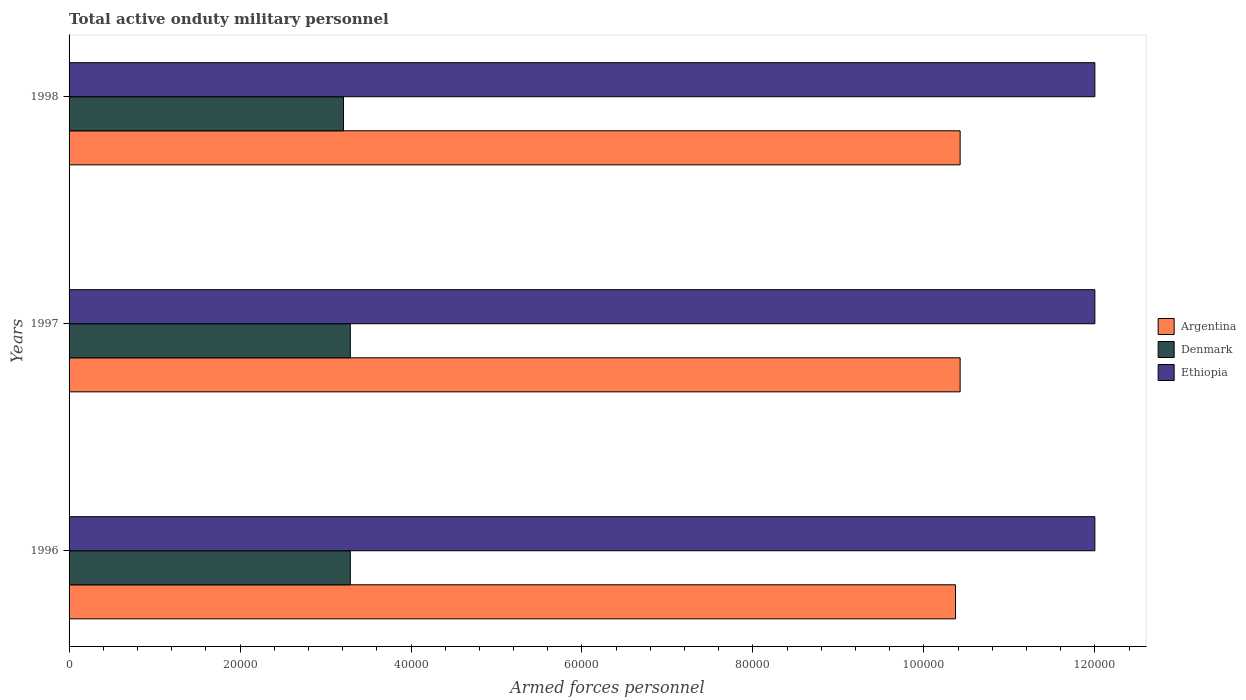How many different coloured bars are there?
Keep it short and to the point. 3. How many groups of bars are there?
Make the answer very short. 3. How many bars are there on the 1st tick from the bottom?
Offer a very short reply. 3. What is the number of armed forces personnel in Ethiopia in 1997?
Give a very brief answer. 1.20e+05. Across all years, what is the maximum number of armed forces personnel in Denmark?
Your answer should be compact. 3.29e+04. Across all years, what is the minimum number of armed forces personnel in Argentina?
Give a very brief answer. 1.04e+05. What is the total number of armed forces personnel in Argentina in the graph?
Offer a terse response. 3.12e+05. What is the difference between the number of armed forces personnel in Denmark in 1997 and that in 1998?
Make the answer very short. 800. What is the difference between the number of armed forces personnel in Ethiopia in 1997 and the number of armed forces personnel in Denmark in 1998?
Your answer should be very brief. 8.79e+04. What is the average number of armed forces personnel in Argentina per year?
Provide a short and direct response. 1.04e+05. In the year 1997, what is the difference between the number of armed forces personnel in Argentina and number of armed forces personnel in Ethiopia?
Keep it short and to the point. -1.58e+04. What is the ratio of the number of armed forces personnel in Argentina in 1996 to that in 1997?
Make the answer very short. 0.99. Is the number of armed forces personnel in Denmark in 1996 less than that in 1997?
Offer a terse response. No. Is the difference between the number of armed forces personnel in Argentina in 1997 and 1998 greater than the difference between the number of armed forces personnel in Ethiopia in 1997 and 1998?
Offer a terse response. No. What is the difference between the highest and the lowest number of armed forces personnel in Argentina?
Keep it short and to the point. 540. What does the 3rd bar from the bottom in 1997 represents?
Keep it short and to the point. Ethiopia. Is it the case that in every year, the sum of the number of armed forces personnel in Argentina and number of armed forces personnel in Denmark is greater than the number of armed forces personnel in Ethiopia?
Offer a terse response. Yes. How many bars are there?
Your answer should be very brief. 9. Are all the bars in the graph horizontal?
Give a very brief answer. Yes. How many years are there in the graph?
Offer a terse response. 3. Are the values on the major ticks of X-axis written in scientific E-notation?
Give a very brief answer. No. Does the graph contain any zero values?
Offer a terse response. No. Does the graph contain grids?
Make the answer very short. No. What is the title of the graph?
Give a very brief answer. Total active onduty military personnel. Does "Zimbabwe" appear as one of the legend labels in the graph?
Your response must be concise. No. What is the label or title of the X-axis?
Offer a very short reply. Armed forces personnel. What is the label or title of the Y-axis?
Give a very brief answer. Years. What is the Armed forces personnel in Argentina in 1996?
Provide a short and direct response. 1.04e+05. What is the Armed forces personnel in Denmark in 1996?
Make the answer very short. 3.29e+04. What is the Armed forces personnel in Ethiopia in 1996?
Keep it short and to the point. 1.20e+05. What is the Armed forces personnel in Argentina in 1997?
Provide a short and direct response. 1.04e+05. What is the Armed forces personnel in Denmark in 1997?
Provide a short and direct response. 3.29e+04. What is the Armed forces personnel of Argentina in 1998?
Your answer should be very brief. 1.04e+05. What is the Armed forces personnel in Denmark in 1998?
Provide a short and direct response. 3.21e+04. Across all years, what is the maximum Armed forces personnel in Argentina?
Provide a short and direct response. 1.04e+05. Across all years, what is the maximum Armed forces personnel of Denmark?
Offer a terse response. 3.29e+04. Across all years, what is the maximum Armed forces personnel in Ethiopia?
Your answer should be compact. 1.20e+05. Across all years, what is the minimum Armed forces personnel in Argentina?
Offer a very short reply. 1.04e+05. Across all years, what is the minimum Armed forces personnel of Denmark?
Offer a terse response. 3.21e+04. Across all years, what is the minimum Armed forces personnel of Ethiopia?
Keep it short and to the point. 1.20e+05. What is the total Armed forces personnel of Argentina in the graph?
Your answer should be compact. 3.12e+05. What is the total Armed forces personnel in Denmark in the graph?
Keep it short and to the point. 9.79e+04. What is the total Armed forces personnel of Ethiopia in the graph?
Provide a succinct answer. 3.60e+05. What is the difference between the Armed forces personnel of Argentina in 1996 and that in 1997?
Give a very brief answer. -540. What is the difference between the Armed forces personnel in Denmark in 1996 and that in 1997?
Provide a succinct answer. 0. What is the difference between the Armed forces personnel of Ethiopia in 1996 and that in 1997?
Make the answer very short. 0. What is the difference between the Armed forces personnel of Argentina in 1996 and that in 1998?
Ensure brevity in your answer.  -540. What is the difference between the Armed forces personnel of Denmark in 1996 and that in 1998?
Your answer should be compact. 800. What is the difference between the Armed forces personnel in Ethiopia in 1996 and that in 1998?
Your answer should be very brief. 0. What is the difference between the Armed forces personnel of Argentina in 1997 and that in 1998?
Offer a terse response. 0. What is the difference between the Armed forces personnel in Denmark in 1997 and that in 1998?
Provide a short and direct response. 800. What is the difference between the Armed forces personnel of Ethiopia in 1997 and that in 1998?
Provide a succinct answer. 0. What is the difference between the Armed forces personnel of Argentina in 1996 and the Armed forces personnel of Denmark in 1997?
Ensure brevity in your answer.  7.08e+04. What is the difference between the Armed forces personnel of Argentina in 1996 and the Armed forces personnel of Ethiopia in 1997?
Provide a short and direct response. -1.63e+04. What is the difference between the Armed forces personnel of Denmark in 1996 and the Armed forces personnel of Ethiopia in 1997?
Offer a terse response. -8.71e+04. What is the difference between the Armed forces personnel of Argentina in 1996 and the Armed forces personnel of Denmark in 1998?
Give a very brief answer. 7.16e+04. What is the difference between the Armed forces personnel in Argentina in 1996 and the Armed forces personnel in Ethiopia in 1998?
Your answer should be very brief. -1.63e+04. What is the difference between the Armed forces personnel in Denmark in 1996 and the Armed forces personnel in Ethiopia in 1998?
Your answer should be very brief. -8.71e+04. What is the difference between the Armed forces personnel of Argentina in 1997 and the Armed forces personnel of Denmark in 1998?
Your answer should be compact. 7.21e+04. What is the difference between the Armed forces personnel in Argentina in 1997 and the Armed forces personnel in Ethiopia in 1998?
Offer a terse response. -1.58e+04. What is the difference between the Armed forces personnel of Denmark in 1997 and the Armed forces personnel of Ethiopia in 1998?
Ensure brevity in your answer.  -8.71e+04. What is the average Armed forces personnel in Argentina per year?
Make the answer very short. 1.04e+05. What is the average Armed forces personnel of Denmark per year?
Offer a very short reply. 3.26e+04. In the year 1996, what is the difference between the Armed forces personnel of Argentina and Armed forces personnel of Denmark?
Ensure brevity in your answer.  7.08e+04. In the year 1996, what is the difference between the Armed forces personnel in Argentina and Armed forces personnel in Ethiopia?
Make the answer very short. -1.63e+04. In the year 1996, what is the difference between the Armed forces personnel of Denmark and Armed forces personnel of Ethiopia?
Keep it short and to the point. -8.71e+04. In the year 1997, what is the difference between the Armed forces personnel in Argentina and Armed forces personnel in Denmark?
Your response must be concise. 7.13e+04. In the year 1997, what is the difference between the Armed forces personnel of Argentina and Armed forces personnel of Ethiopia?
Provide a short and direct response. -1.58e+04. In the year 1997, what is the difference between the Armed forces personnel of Denmark and Armed forces personnel of Ethiopia?
Keep it short and to the point. -8.71e+04. In the year 1998, what is the difference between the Armed forces personnel in Argentina and Armed forces personnel in Denmark?
Your answer should be compact. 7.21e+04. In the year 1998, what is the difference between the Armed forces personnel in Argentina and Armed forces personnel in Ethiopia?
Provide a short and direct response. -1.58e+04. In the year 1998, what is the difference between the Armed forces personnel of Denmark and Armed forces personnel of Ethiopia?
Offer a terse response. -8.79e+04. What is the ratio of the Armed forces personnel in Ethiopia in 1996 to that in 1997?
Provide a short and direct response. 1. What is the ratio of the Armed forces personnel in Denmark in 1996 to that in 1998?
Your answer should be very brief. 1.02. What is the ratio of the Armed forces personnel in Ethiopia in 1996 to that in 1998?
Offer a terse response. 1. What is the ratio of the Armed forces personnel in Denmark in 1997 to that in 1998?
Ensure brevity in your answer.  1.02. What is the difference between the highest and the lowest Armed forces personnel of Argentina?
Ensure brevity in your answer.  540. What is the difference between the highest and the lowest Armed forces personnel in Denmark?
Keep it short and to the point. 800. What is the difference between the highest and the lowest Armed forces personnel of Ethiopia?
Your response must be concise. 0. 